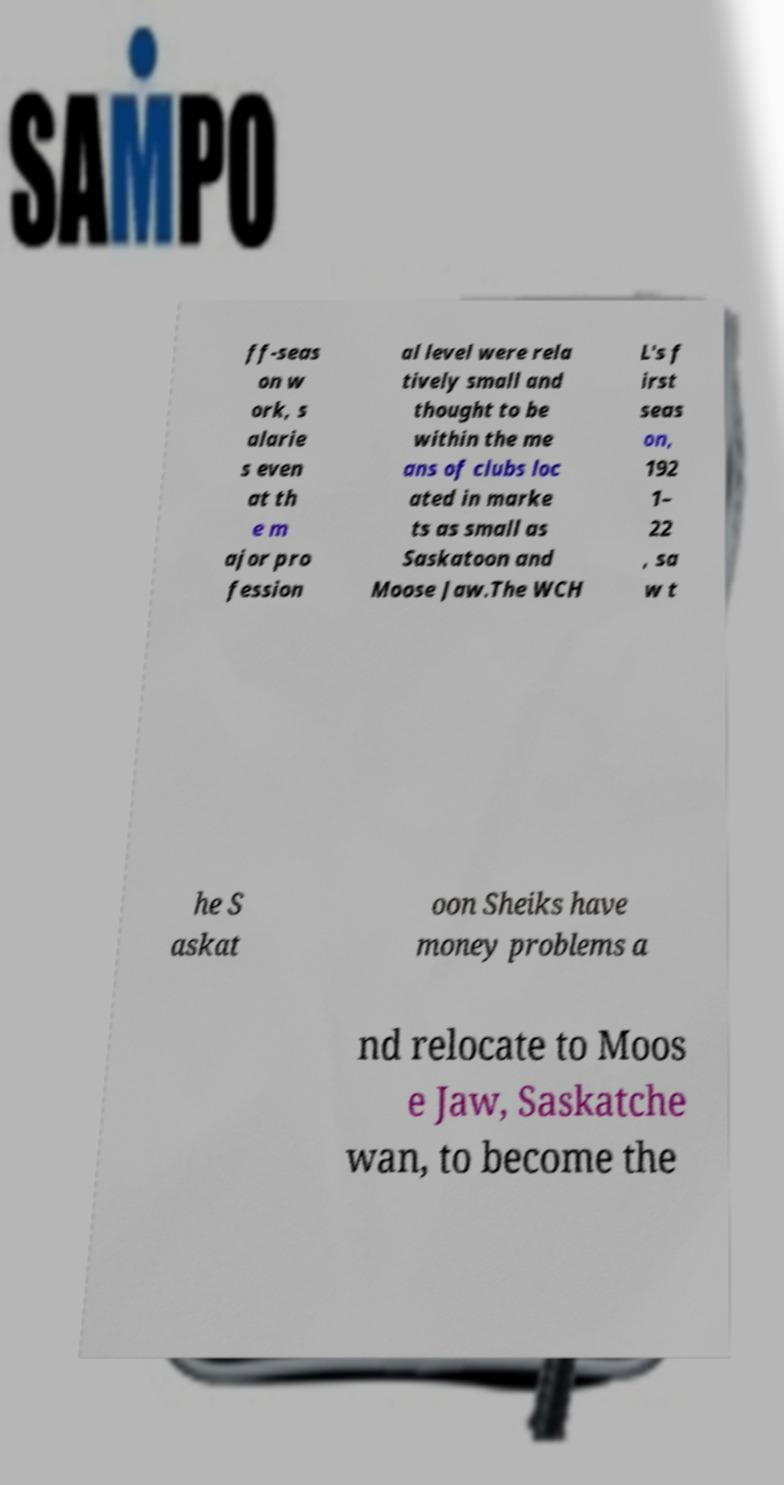Please read and relay the text visible in this image. What does it say? ff-seas on w ork, s alarie s even at th e m ajor pro fession al level were rela tively small and thought to be within the me ans of clubs loc ated in marke ts as small as Saskatoon and Moose Jaw.The WCH L's f irst seas on, 192 1– 22 , sa w t he S askat oon Sheiks have money problems a nd relocate to Moos e Jaw, Saskatche wan, to become the 